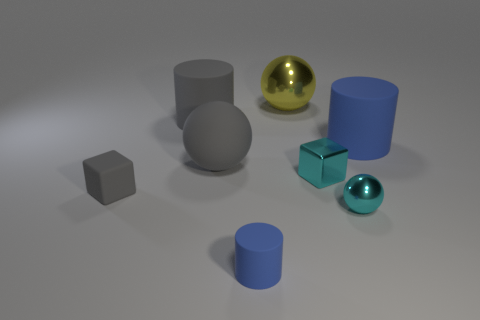Subtract all blue balls. How many blue cylinders are left? 2 Subtract 1 balls. How many balls are left? 2 Subtract all small shiny spheres. How many spheres are left? 2 Add 2 large blue matte things. How many objects exist? 10 Add 4 small purple rubber cubes. How many small purple rubber cubes exist? 4 Subtract 0 green cubes. How many objects are left? 8 Subtract all cylinders. How many objects are left? 5 Subtract all gray cubes. Subtract all yellow spheres. How many cubes are left? 1 Subtract all small brown metallic spheres. Subtract all balls. How many objects are left? 5 Add 1 small gray things. How many small gray things are left? 2 